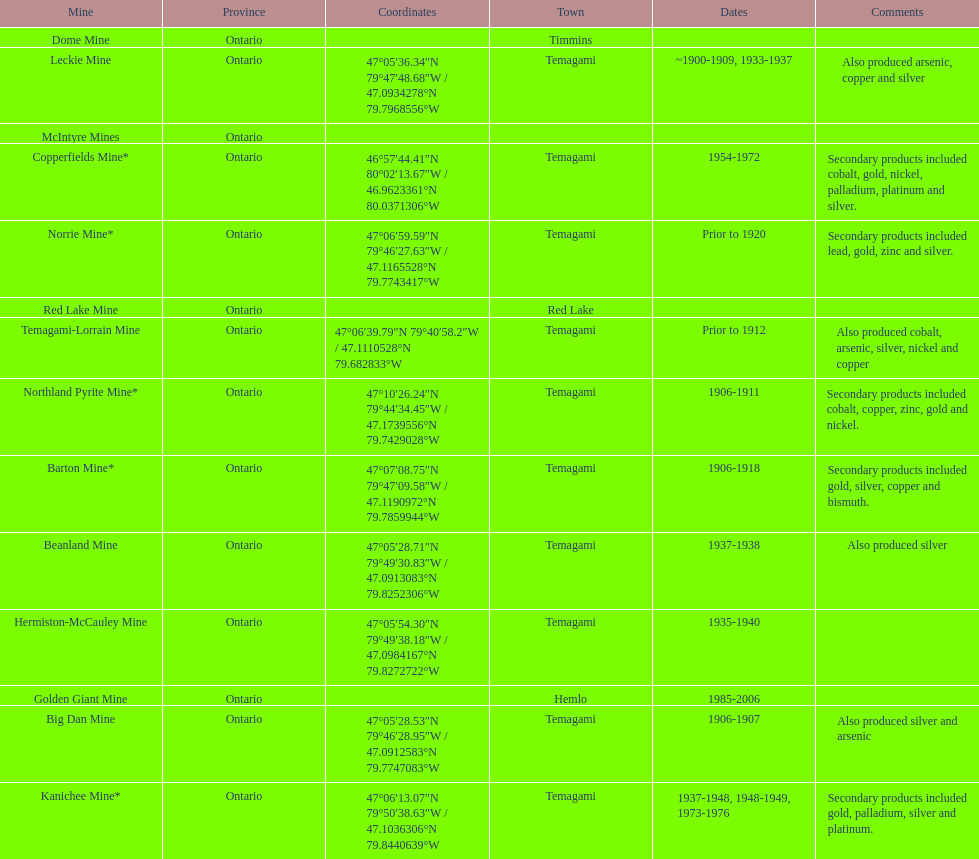Name a gold mine that was open at least 10 years. Barton Mine. 